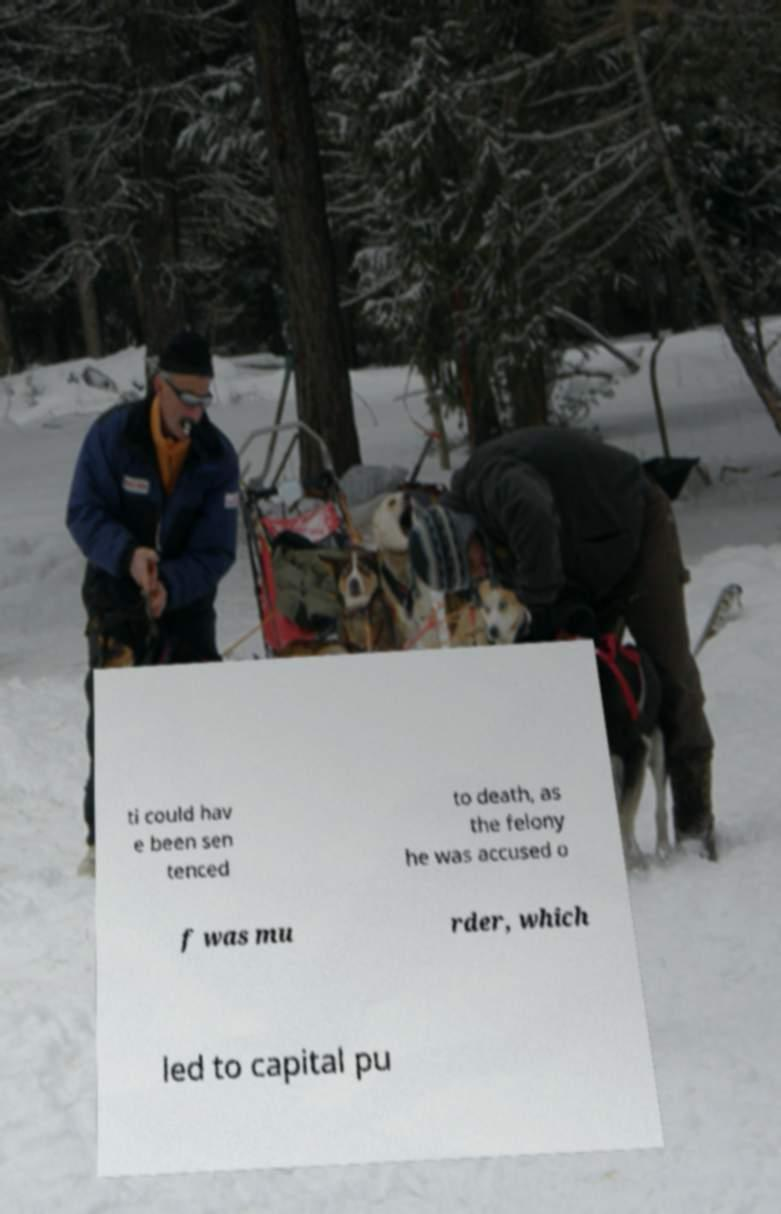Could you assist in decoding the text presented in this image and type it out clearly? ti could hav e been sen tenced to death, as the felony he was accused o f was mu rder, which led to capital pu 